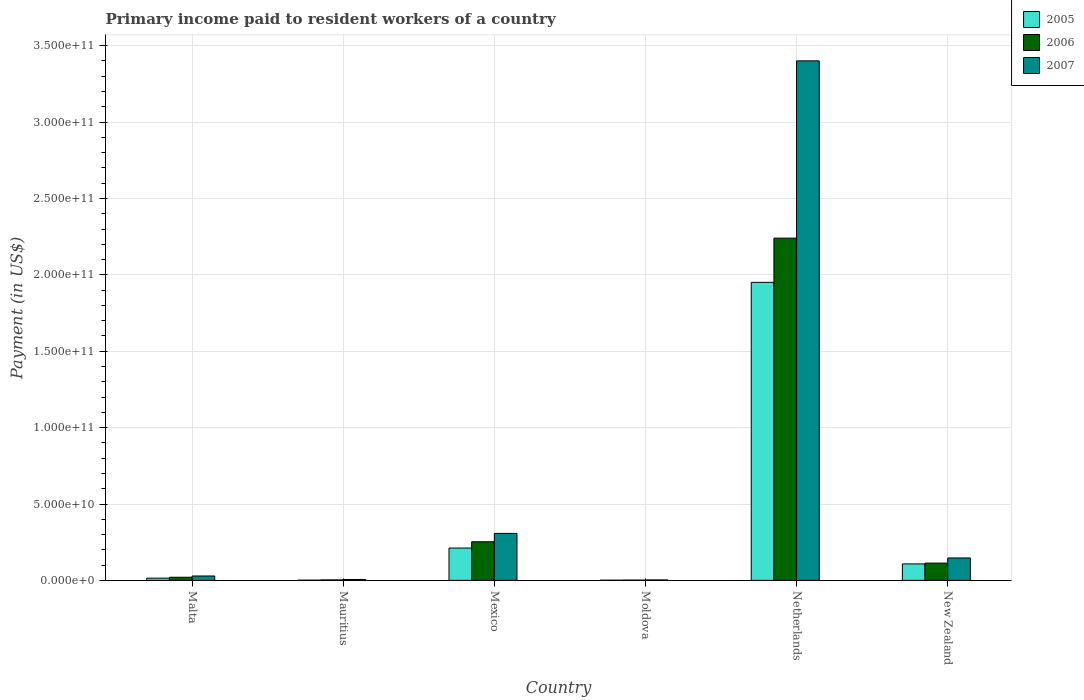How many groups of bars are there?
Your answer should be compact. 6. Are the number of bars per tick equal to the number of legend labels?
Offer a terse response. Yes. Are the number of bars on each tick of the X-axis equal?
Provide a succinct answer. Yes. How many bars are there on the 4th tick from the left?
Offer a terse response. 3. How many bars are there on the 2nd tick from the right?
Make the answer very short. 3. What is the label of the 1st group of bars from the left?
Ensure brevity in your answer.  Malta. What is the amount paid to workers in 2007 in New Zealand?
Give a very brief answer. 1.47e+1. Across all countries, what is the maximum amount paid to workers in 2007?
Your answer should be compact. 3.40e+11. Across all countries, what is the minimum amount paid to workers in 2005?
Your answer should be compact. 1.28e+08. In which country was the amount paid to workers in 2005 maximum?
Give a very brief answer. Netherlands. In which country was the amount paid to workers in 2006 minimum?
Provide a short and direct response. Moldova. What is the total amount paid to workers in 2007 in the graph?
Give a very brief answer. 3.89e+11. What is the difference between the amount paid to workers in 2006 in Mauritius and that in New Zealand?
Offer a very short reply. -1.10e+1. What is the difference between the amount paid to workers in 2006 in Mexico and the amount paid to workers in 2005 in Netherlands?
Provide a short and direct response. -1.70e+11. What is the average amount paid to workers in 2007 per country?
Your answer should be very brief. 6.49e+1. What is the difference between the amount paid to workers of/in 2007 and amount paid to workers of/in 2005 in Mauritius?
Your answer should be very brief. 4.42e+08. What is the ratio of the amount paid to workers in 2007 in Mauritius to that in Netherlands?
Ensure brevity in your answer.  0. What is the difference between the highest and the second highest amount paid to workers in 2007?
Offer a very short reply. 3.25e+11. What is the difference between the highest and the lowest amount paid to workers in 2005?
Provide a short and direct response. 1.95e+11. Is it the case that in every country, the sum of the amount paid to workers in 2006 and amount paid to workers in 2007 is greater than the amount paid to workers in 2005?
Provide a succinct answer. Yes. How many countries are there in the graph?
Offer a terse response. 6. What is the difference between two consecutive major ticks on the Y-axis?
Make the answer very short. 5.00e+1. Does the graph contain any zero values?
Your response must be concise. No. How are the legend labels stacked?
Offer a very short reply. Vertical. What is the title of the graph?
Ensure brevity in your answer.  Primary income paid to resident workers of a country. What is the label or title of the Y-axis?
Keep it short and to the point. Payment (in US$). What is the Payment (in US$) of 2005 in Malta?
Provide a succinct answer. 1.45e+09. What is the Payment (in US$) in 2006 in Malta?
Provide a succinct answer. 2.05e+09. What is the Payment (in US$) of 2007 in Malta?
Make the answer very short. 2.88e+09. What is the Payment (in US$) in 2005 in Mauritius?
Provide a short and direct response. 1.51e+08. What is the Payment (in US$) of 2006 in Mauritius?
Your response must be concise. 3.24e+08. What is the Payment (in US$) in 2007 in Mauritius?
Provide a short and direct response. 5.93e+08. What is the Payment (in US$) of 2005 in Mexico?
Offer a very short reply. 2.12e+1. What is the Payment (in US$) of 2006 in Mexico?
Your answer should be compact. 2.53e+1. What is the Payment (in US$) in 2007 in Mexico?
Keep it short and to the point. 3.08e+1. What is the Payment (in US$) in 2005 in Moldova?
Your answer should be compact. 1.28e+08. What is the Payment (in US$) of 2006 in Moldova?
Ensure brevity in your answer.  2.03e+08. What is the Payment (in US$) of 2007 in Moldova?
Offer a terse response. 2.94e+08. What is the Payment (in US$) in 2005 in Netherlands?
Your answer should be compact. 1.95e+11. What is the Payment (in US$) in 2006 in Netherlands?
Ensure brevity in your answer.  2.24e+11. What is the Payment (in US$) of 2007 in Netherlands?
Your answer should be compact. 3.40e+11. What is the Payment (in US$) in 2005 in New Zealand?
Ensure brevity in your answer.  1.08e+1. What is the Payment (in US$) of 2006 in New Zealand?
Keep it short and to the point. 1.13e+1. What is the Payment (in US$) in 2007 in New Zealand?
Your answer should be very brief. 1.47e+1. Across all countries, what is the maximum Payment (in US$) of 2005?
Make the answer very short. 1.95e+11. Across all countries, what is the maximum Payment (in US$) of 2006?
Make the answer very short. 2.24e+11. Across all countries, what is the maximum Payment (in US$) in 2007?
Offer a terse response. 3.40e+11. Across all countries, what is the minimum Payment (in US$) in 2005?
Provide a succinct answer. 1.28e+08. Across all countries, what is the minimum Payment (in US$) in 2006?
Provide a short and direct response. 2.03e+08. Across all countries, what is the minimum Payment (in US$) in 2007?
Make the answer very short. 2.94e+08. What is the total Payment (in US$) of 2005 in the graph?
Keep it short and to the point. 2.29e+11. What is the total Payment (in US$) of 2006 in the graph?
Keep it short and to the point. 2.63e+11. What is the total Payment (in US$) in 2007 in the graph?
Give a very brief answer. 3.89e+11. What is the difference between the Payment (in US$) of 2005 in Malta and that in Mauritius?
Ensure brevity in your answer.  1.30e+09. What is the difference between the Payment (in US$) in 2006 in Malta and that in Mauritius?
Your answer should be very brief. 1.73e+09. What is the difference between the Payment (in US$) in 2007 in Malta and that in Mauritius?
Your answer should be compact. 2.29e+09. What is the difference between the Payment (in US$) of 2005 in Malta and that in Mexico?
Your response must be concise. -1.97e+1. What is the difference between the Payment (in US$) of 2006 in Malta and that in Mexico?
Ensure brevity in your answer.  -2.32e+1. What is the difference between the Payment (in US$) in 2007 in Malta and that in Mexico?
Make the answer very short. -2.79e+1. What is the difference between the Payment (in US$) in 2005 in Malta and that in Moldova?
Your answer should be very brief. 1.33e+09. What is the difference between the Payment (in US$) in 2006 in Malta and that in Moldova?
Offer a terse response. 1.85e+09. What is the difference between the Payment (in US$) of 2007 in Malta and that in Moldova?
Offer a terse response. 2.59e+09. What is the difference between the Payment (in US$) of 2005 in Malta and that in Netherlands?
Provide a succinct answer. -1.94e+11. What is the difference between the Payment (in US$) in 2006 in Malta and that in Netherlands?
Make the answer very short. -2.22e+11. What is the difference between the Payment (in US$) in 2007 in Malta and that in Netherlands?
Offer a very short reply. -3.37e+11. What is the difference between the Payment (in US$) of 2005 in Malta and that in New Zealand?
Offer a very short reply. -9.34e+09. What is the difference between the Payment (in US$) in 2006 in Malta and that in New Zealand?
Give a very brief answer. -9.26e+09. What is the difference between the Payment (in US$) in 2007 in Malta and that in New Zealand?
Your answer should be very brief. -1.18e+1. What is the difference between the Payment (in US$) in 2005 in Mauritius and that in Mexico?
Provide a short and direct response. -2.10e+1. What is the difference between the Payment (in US$) in 2006 in Mauritius and that in Mexico?
Offer a terse response. -2.50e+1. What is the difference between the Payment (in US$) in 2007 in Mauritius and that in Mexico?
Keep it short and to the point. -3.02e+1. What is the difference between the Payment (in US$) of 2005 in Mauritius and that in Moldova?
Keep it short and to the point. 2.30e+07. What is the difference between the Payment (in US$) of 2006 in Mauritius and that in Moldova?
Offer a terse response. 1.20e+08. What is the difference between the Payment (in US$) in 2007 in Mauritius and that in Moldova?
Provide a succinct answer. 3.00e+08. What is the difference between the Payment (in US$) of 2005 in Mauritius and that in Netherlands?
Make the answer very short. -1.95e+11. What is the difference between the Payment (in US$) in 2006 in Mauritius and that in Netherlands?
Make the answer very short. -2.24e+11. What is the difference between the Payment (in US$) in 2007 in Mauritius and that in Netherlands?
Offer a very short reply. -3.39e+11. What is the difference between the Payment (in US$) in 2005 in Mauritius and that in New Zealand?
Keep it short and to the point. -1.06e+1. What is the difference between the Payment (in US$) of 2006 in Mauritius and that in New Zealand?
Your response must be concise. -1.10e+1. What is the difference between the Payment (in US$) of 2007 in Mauritius and that in New Zealand?
Ensure brevity in your answer.  -1.41e+1. What is the difference between the Payment (in US$) in 2005 in Mexico and that in Moldova?
Offer a terse response. 2.11e+1. What is the difference between the Payment (in US$) of 2006 in Mexico and that in Moldova?
Make the answer very short. 2.51e+1. What is the difference between the Payment (in US$) of 2007 in Mexico and that in Moldova?
Ensure brevity in your answer.  3.05e+1. What is the difference between the Payment (in US$) in 2005 in Mexico and that in Netherlands?
Offer a very short reply. -1.74e+11. What is the difference between the Payment (in US$) of 2006 in Mexico and that in Netherlands?
Provide a succinct answer. -1.99e+11. What is the difference between the Payment (in US$) of 2007 in Mexico and that in Netherlands?
Ensure brevity in your answer.  -3.09e+11. What is the difference between the Payment (in US$) of 2005 in Mexico and that in New Zealand?
Offer a terse response. 1.04e+1. What is the difference between the Payment (in US$) of 2006 in Mexico and that in New Zealand?
Your answer should be very brief. 1.40e+1. What is the difference between the Payment (in US$) of 2007 in Mexico and that in New Zealand?
Offer a very short reply. 1.61e+1. What is the difference between the Payment (in US$) of 2005 in Moldova and that in Netherlands?
Keep it short and to the point. -1.95e+11. What is the difference between the Payment (in US$) of 2006 in Moldova and that in Netherlands?
Your answer should be compact. -2.24e+11. What is the difference between the Payment (in US$) in 2007 in Moldova and that in Netherlands?
Keep it short and to the point. -3.40e+11. What is the difference between the Payment (in US$) in 2005 in Moldova and that in New Zealand?
Provide a short and direct response. -1.07e+1. What is the difference between the Payment (in US$) of 2006 in Moldova and that in New Zealand?
Ensure brevity in your answer.  -1.11e+1. What is the difference between the Payment (in US$) in 2007 in Moldova and that in New Zealand?
Your answer should be very brief. -1.44e+1. What is the difference between the Payment (in US$) in 2005 in Netherlands and that in New Zealand?
Offer a very short reply. 1.84e+11. What is the difference between the Payment (in US$) in 2006 in Netherlands and that in New Zealand?
Provide a succinct answer. 2.13e+11. What is the difference between the Payment (in US$) in 2007 in Netherlands and that in New Zealand?
Keep it short and to the point. 3.25e+11. What is the difference between the Payment (in US$) in 2005 in Malta and the Payment (in US$) in 2006 in Mauritius?
Your answer should be very brief. 1.13e+09. What is the difference between the Payment (in US$) of 2005 in Malta and the Payment (in US$) of 2007 in Mauritius?
Give a very brief answer. 8.62e+08. What is the difference between the Payment (in US$) of 2006 in Malta and the Payment (in US$) of 2007 in Mauritius?
Provide a short and direct response. 1.46e+09. What is the difference between the Payment (in US$) in 2005 in Malta and the Payment (in US$) in 2006 in Mexico?
Your response must be concise. -2.38e+1. What is the difference between the Payment (in US$) in 2005 in Malta and the Payment (in US$) in 2007 in Mexico?
Provide a short and direct response. -2.93e+1. What is the difference between the Payment (in US$) of 2006 in Malta and the Payment (in US$) of 2007 in Mexico?
Keep it short and to the point. -2.87e+1. What is the difference between the Payment (in US$) of 2005 in Malta and the Payment (in US$) of 2006 in Moldova?
Provide a succinct answer. 1.25e+09. What is the difference between the Payment (in US$) in 2005 in Malta and the Payment (in US$) in 2007 in Moldova?
Keep it short and to the point. 1.16e+09. What is the difference between the Payment (in US$) in 2006 in Malta and the Payment (in US$) in 2007 in Moldova?
Make the answer very short. 1.76e+09. What is the difference between the Payment (in US$) of 2005 in Malta and the Payment (in US$) of 2006 in Netherlands?
Ensure brevity in your answer.  -2.23e+11. What is the difference between the Payment (in US$) of 2005 in Malta and the Payment (in US$) of 2007 in Netherlands?
Provide a succinct answer. -3.39e+11. What is the difference between the Payment (in US$) in 2006 in Malta and the Payment (in US$) in 2007 in Netherlands?
Your answer should be very brief. -3.38e+11. What is the difference between the Payment (in US$) in 2005 in Malta and the Payment (in US$) in 2006 in New Zealand?
Keep it short and to the point. -9.86e+09. What is the difference between the Payment (in US$) in 2005 in Malta and the Payment (in US$) in 2007 in New Zealand?
Ensure brevity in your answer.  -1.32e+1. What is the difference between the Payment (in US$) in 2006 in Malta and the Payment (in US$) in 2007 in New Zealand?
Provide a short and direct response. -1.26e+1. What is the difference between the Payment (in US$) in 2005 in Mauritius and the Payment (in US$) in 2006 in Mexico?
Provide a succinct answer. -2.51e+1. What is the difference between the Payment (in US$) in 2005 in Mauritius and the Payment (in US$) in 2007 in Mexico?
Your answer should be very brief. -3.06e+1. What is the difference between the Payment (in US$) of 2006 in Mauritius and the Payment (in US$) of 2007 in Mexico?
Ensure brevity in your answer.  -3.04e+1. What is the difference between the Payment (in US$) in 2005 in Mauritius and the Payment (in US$) in 2006 in Moldova?
Your answer should be compact. -5.20e+07. What is the difference between the Payment (in US$) of 2005 in Mauritius and the Payment (in US$) of 2007 in Moldova?
Keep it short and to the point. -1.42e+08. What is the difference between the Payment (in US$) in 2006 in Mauritius and the Payment (in US$) in 2007 in Moldova?
Make the answer very short. 3.02e+07. What is the difference between the Payment (in US$) of 2005 in Mauritius and the Payment (in US$) of 2006 in Netherlands?
Your answer should be very brief. -2.24e+11. What is the difference between the Payment (in US$) in 2005 in Mauritius and the Payment (in US$) in 2007 in Netherlands?
Your response must be concise. -3.40e+11. What is the difference between the Payment (in US$) of 2006 in Mauritius and the Payment (in US$) of 2007 in Netherlands?
Offer a terse response. -3.40e+11. What is the difference between the Payment (in US$) of 2005 in Mauritius and the Payment (in US$) of 2006 in New Zealand?
Your response must be concise. -1.12e+1. What is the difference between the Payment (in US$) in 2005 in Mauritius and the Payment (in US$) in 2007 in New Zealand?
Make the answer very short. -1.45e+1. What is the difference between the Payment (in US$) in 2006 in Mauritius and the Payment (in US$) in 2007 in New Zealand?
Your answer should be very brief. -1.44e+1. What is the difference between the Payment (in US$) in 2005 in Mexico and the Payment (in US$) in 2006 in Moldova?
Your answer should be very brief. 2.10e+1. What is the difference between the Payment (in US$) of 2005 in Mexico and the Payment (in US$) of 2007 in Moldova?
Ensure brevity in your answer.  2.09e+1. What is the difference between the Payment (in US$) of 2006 in Mexico and the Payment (in US$) of 2007 in Moldova?
Your answer should be very brief. 2.50e+1. What is the difference between the Payment (in US$) of 2005 in Mexico and the Payment (in US$) of 2006 in Netherlands?
Your answer should be compact. -2.03e+11. What is the difference between the Payment (in US$) of 2005 in Mexico and the Payment (in US$) of 2007 in Netherlands?
Make the answer very short. -3.19e+11. What is the difference between the Payment (in US$) of 2006 in Mexico and the Payment (in US$) of 2007 in Netherlands?
Your answer should be compact. -3.15e+11. What is the difference between the Payment (in US$) in 2005 in Mexico and the Payment (in US$) in 2006 in New Zealand?
Give a very brief answer. 9.87e+09. What is the difference between the Payment (in US$) of 2005 in Mexico and the Payment (in US$) of 2007 in New Zealand?
Your answer should be compact. 6.50e+09. What is the difference between the Payment (in US$) in 2006 in Mexico and the Payment (in US$) in 2007 in New Zealand?
Provide a succinct answer. 1.06e+1. What is the difference between the Payment (in US$) of 2005 in Moldova and the Payment (in US$) of 2006 in Netherlands?
Keep it short and to the point. -2.24e+11. What is the difference between the Payment (in US$) in 2005 in Moldova and the Payment (in US$) in 2007 in Netherlands?
Offer a terse response. -3.40e+11. What is the difference between the Payment (in US$) of 2006 in Moldova and the Payment (in US$) of 2007 in Netherlands?
Give a very brief answer. -3.40e+11. What is the difference between the Payment (in US$) of 2005 in Moldova and the Payment (in US$) of 2006 in New Zealand?
Make the answer very short. -1.12e+1. What is the difference between the Payment (in US$) in 2005 in Moldova and the Payment (in US$) in 2007 in New Zealand?
Your answer should be very brief. -1.46e+1. What is the difference between the Payment (in US$) in 2006 in Moldova and the Payment (in US$) in 2007 in New Zealand?
Offer a terse response. -1.45e+1. What is the difference between the Payment (in US$) in 2005 in Netherlands and the Payment (in US$) in 2006 in New Zealand?
Your answer should be very brief. 1.84e+11. What is the difference between the Payment (in US$) of 2005 in Netherlands and the Payment (in US$) of 2007 in New Zealand?
Your answer should be very brief. 1.80e+11. What is the difference between the Payment (in US$) of 2006 in Netherlands and the Payment (in US$) of 2007 in New Zealand?
Provide a succinct answer. 2.09e+11. What is the average Payment (in US$) of 2005 per country?
Make the answer very short. 3.81e+1. What is the average Payment (in US$) of 2006 per country?
Provide a short and direct response. 4.39e+1. What is the average Payment (in US$) of 2007 per country?
Provide a short and direct response. 6.49e+1. What is the difference between the Payment (in US$) of 2005 and Payment (in US$) of 2006 in Malta?
Your answer should be compact. -5.99e+08. What is the difference between the Payment (in US$) of 2005 and Payment (in US$) of 2007 in Malta?
Ensure brevity in your answer.  -1.42e+09. What is the difference between the Payment (in US$) of 2006 and Payment (in US$) of 2007 in Malta?
Provide a succinct answer. -8.25e+08. What is the difference between the Payment (in US$) in 2005 and Payment (in US$) in 2006 in Mauritius?
Keep it short and to the point. -1.72e+08. What is the difference between the Payment (in US$) in 2005 and Payment (in US$) in 2007 in Mauritius?
Make the answer very short. -4.42e+08. What is the difference between the Payment (in US$) in 2006 and Payment (in US$) in 2007 in Mauritius?
Keep it short and to the point. -2.69e+08. What is the difference between the Payment (in US$) in 2005 and Payment (in US$) in 2006 in Mexico?
Your response must be concise. -4.10e+09. What is the difference between the Payment (in US$) of 2005 and Payment (in US$) of 2007 in Mexico?
Give a very brief answer. -9.58e+09. What is the difference between the Payment (in US$) in 2006 and Payment (in US$) in 2007 in Mexico?
Your answer should be compact. -5.48e+09. What is the difference between the Payment (in US$) in 2005 and Payment (in US$) in 2006 in Moldova?
Provide a succinct answer. -7.50e+07. What is the difference between the Payment (in US$) of 2005 and Payment (in US$) of 2007 in Moldova?
Offer a terse response. -1.65e+08. What is the difference between the Payment (in US$) in 2006 and Payment (in US$) in 2007 in Moldova?
Your answer should be very brief. -9.03e+07. What is the difference between the Payment (in US$) in 2005 and Payment (in US$) in 2006 in Netherlands?
Your answer should be compact. -2.89e+1. What is the difference between the Payment (in US$) in 2005 and Payment (in US$) in 2007 in Netherlands?
Give a very brief answer. -1.45e+11. What is the difference between the Payment (in US$) of 2006 and Payment (in US$) of 2007 in Netherlands?
Your response must be concise. -1.16e+11. What is the difference between the Payment (in US$) of 2005 and Payment (in US$) of 2006 in New Zealand?
Offer a very short reply. -5.20e+08. What is the difference between the Payment (in US$) in 2005 and Payment (in US$) in 2007 in New Zealand?
Keep it short and to the point. -3.88e+09. What is the difference between the Payment (in US$) of 2006 and Payment (in US$) of 2007 in New Zealand?
Give a very brief answer. -3.36e+09. What is the ratio of the Payment (in US$) in 2005 in Malta to that in Mauritius?
Provide a succinct answer. 9.61. What is the ratio of the Payment (in US$) of 2006 in Malta to that in Mauritius?
Provide a short and direct response. 6.34. What is the ratio of the Payment (in US$) in 2007 in Malta to that in Mauritius?
Provide a short and direct response. 4.85. What is the ratio of the Payment (in US$) of 2005 in Malta to that in Mexico?
Your response must be concise. 0.07. What is the ratio of the Payment (in US$) in 2006 in Malta to that in Mexico?
Your response must be concise. 0.08. What is the ratio of the Payment (in US$) in 2007 in Malta to that in Mexico?
Your answer should be very brief. 0.09. What is the ratio of the Payment (in US$) in 2005 in Malta to that in Moldova?
Give a very brief answer. 11.33. What is the ratio of the Payment (in US$) in 2006 in Malta to that in Moldova?
Your answer should be very brief. 10.1. What is the ratio of the Payment (in US$) in 2007 in Malta to that in Moldova?
Offer a terse response. 9.8. What is the ratio of the Payment (in US$) in 2005 in Malta to that in Netherlands?
Offer a very short reply. 0.01. What is the ratio of the Payment (in US$) of 2006 in Malta to that in Netherlands?
Keep it short and to the point. 0.01. What is the ratio of the Payment (in US$) in 2007 in Malta to that in Netherlands?
Provide a short and direct response. 0.01. What is the ratio of the Payment (in US$) in 2005 in Malta to that in New Zealand?
Keep it short and to the point. 0.13. What is the ratio of the Payment (in US$) of 2006 in Malta to that in New Zealand?
Give a very brief answer. 0.18. What is the ratio of the Payment (in US$) of 2007 in Malta to that in New Zealand?
Provide a succinct answer. 0.2. What is the ratio of the Payment (in US$) in 2005 in Mauritius to that in Mexico?
Provide a short and direct response. 0.01. What is the ratio of the Payment (in US$) of 2006 in Mauritius to that in Mexico?
Ensure brevity in your answer.  0.01. What is the ratio of the Payment (in US$) of 2007 in Mauritius to that in Mexico?
Give a very brief answer. 0.02. What is the ratio of the Payment (in US$) of 2005 in Mauritius to that in Moldova?
Your answer should be compact. 1.18. What is the ratio of the Payment (in US$) of 2006 in Mauritius to that in Moldova?
Provide a succinct answer. 1.59. What is the ratio of the Payment (in US$) in 2007 in Mauritius to that in Moldova?
Give a very brief answer. 2.02. What is the ratio of the Payment (in US$) in 2005 in Mauritius to that in Netherlands?
Your response must be concise. 0. What is the ratio of the Payment (in US$) in 2006 in Mauritius to that in Netherlands?
Make the answer very short. 0. What is the ratio of the Payment (in US$) in 2007 in Mauritius to that in Netherlands?
Your answer should be very brief. 0. What is the ratio of the Payment (in US$) of 2005 in Mauritius to that in New Zealand?
Your response must be concise. 0.01. What is the ratio of the Payment (in US$) in 2006 in Mauritius to that in New Zealand?
Provide a short and direct response. 0.03. What is the ratio of the Payment (in US$) in 2007 in Mauritius to that in New Zealand?
Offer a very short reply. 0.04. What is the ratio of the Payment (in US$) in 2005 in Mexico to that in Moldova?
Provide a short and direct response. 164.99. What is the ratio of the Payment (in US$) in 2006 in Mexico to that in Moldova?
Your answer should be compact. 124.33. What is the ratio of the Payment (in US$) in 2007 in Mexico to that in Moldova?
Your response must be concise. 104.75. What is the ratio of the Payment (in US$) in 2005 in Mexico to that in Netherlands?
Provide a succinct answer. 0.11. What is the ratio of the Payment (in US$) in 2006 in Mexico to that in Netherlands?
Provide a short and direct response. 0.11. What is the ratio of the Payment (in US$) of 2007 in Mexico to that in Netherlands?
Give a very brief answer. 0.09. What is the ratio of the Payment (in US$) of 2005 in Mexico to that in New Zealand?
Make the answer very short. 1.96. What is the ratio of the Payment (in US$) in 2006 in Mexico to that in New Zealand?
Your answer should be very brief. 2.23. What is the ratio of the Payment (in US$) of 2007 in Mexico to that in New Zealand?
Ensure brevity in your answer.  2.1. What is the ratio of the Payment (in US$) of 2005 in Moldova to that in Netherlands?
Make the answer very short. 0. What is the ratio of the Payment (in US$) in 2006 in Moldova to that in Netherlands?
Ensure brevity in your answer.  0. What is the ratio of the Payment (in US$) of 2007 in Moldova to that in Netherlands?
Your response must be concise. 0. What is the ratio of the Payment (in US$) of 2005 in Moldova to that in New Zealand?
Provide a succinct answer. 0.01. What is the ratio of the Payment (in US$) in 2006 in Moldova to that in New Zealand?
Offer a terse response. 0.02. What is the ratio of the Payment (in US$) of 2005 in Netherlands to that in New Zealand?
Keep it short and to the point. 18.07. What is the ratio of the Payment (in US$) of 2006 in Netherlands to that in New Zealand?
Make the answer very short. 19.8. What is the ratio of the Payment (in US$) in 2007 in Netherlands to that in New Zealand?
Ensure brevity in your answer.  23.17. What is the difference between the highest and the second highest Payment (in US$) of 2005?
Ensure brevity in your answer.  1.74e+11. What is the difference between the highest and the second highest Payment (in US$) in 2006?
Your answer should be very brief. 1.99e+11. What is the difference between the highest and the second highest Payment (in US$) of 2007?
Keep it short and to the point. 3.09e+11. What is the difference between the highest and the lowest Payment (in US$) in 2005?
Provide a short and direct response. 1.95e+11. What is the difference between the highest and the lowest Payment (in US$) in 2006?
Your answer should be compact. 2.24e+11. What is the difference between the highest and the lowest Payment (in US$) of 2007?
Ensure brevity in your answer.  3.40e+11. 